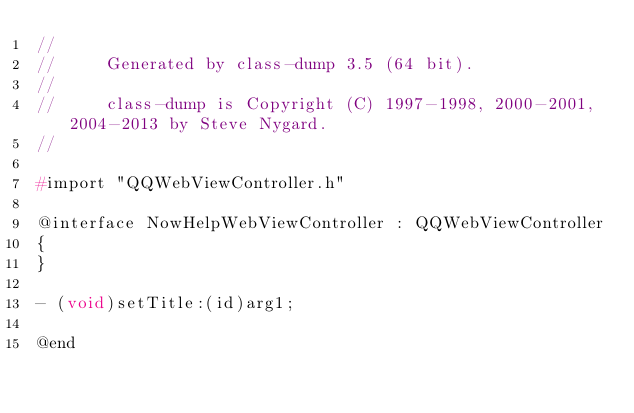<code> <loc_0><loc_0><loc_500><loc_500><_C_>//
//     Generated by class-dump 3.5 (64 bit).
//
//     class-dump is Copyright (C) 1997-1998, 2000-2001, 2004-2013 by Steve Nygard.
//

#import "QQWebViewController.h"

@interface NowHelpWebViewController : QQWebViewController
{
}

- (void)setTitle:(id)arg1;

@end

</code> 